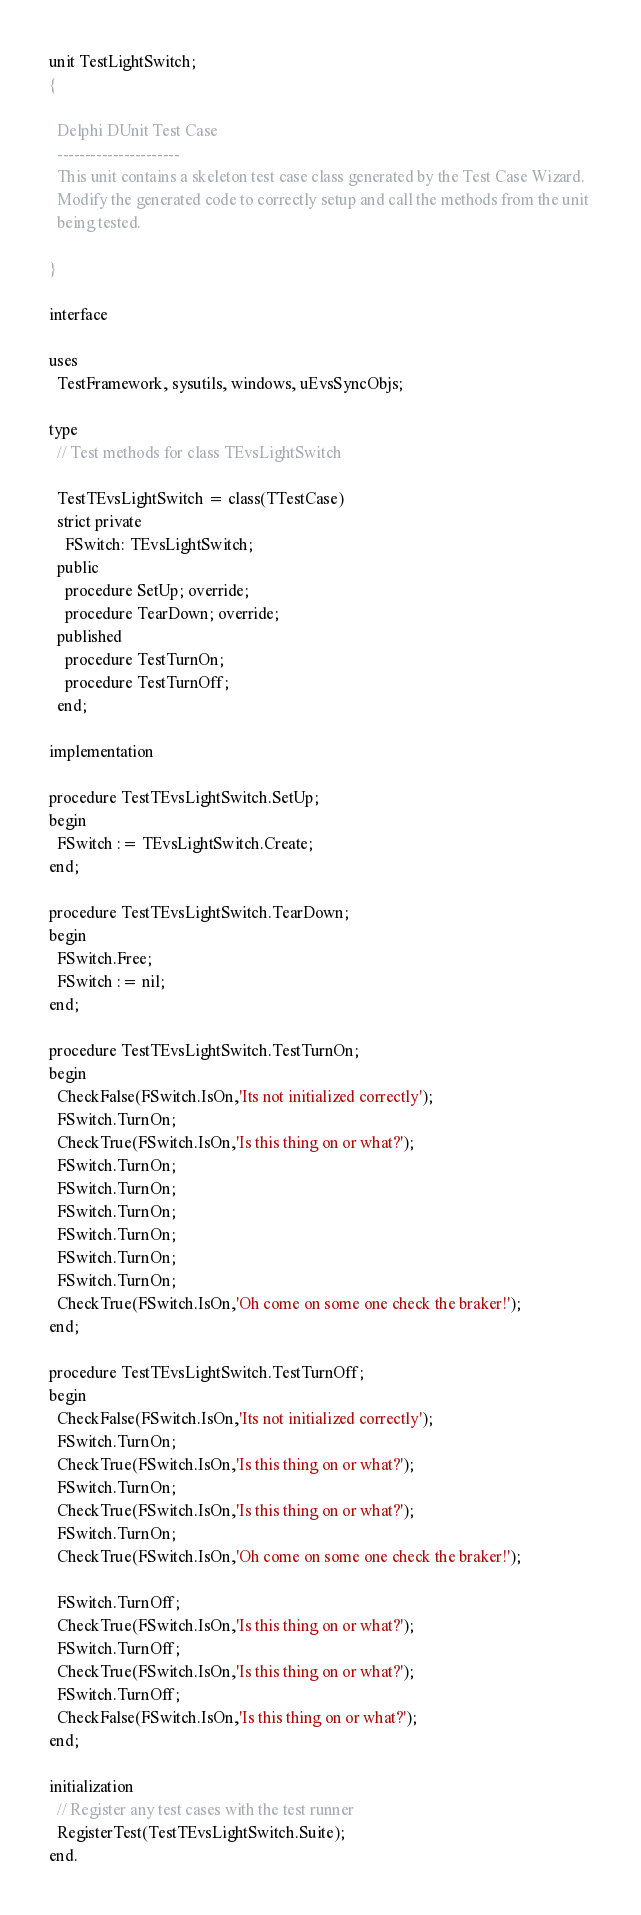Convert code to text. <code><loc_0><loc_0><loc_500><loc_500><_Pascal_>unit TestLightSwitch;
{

  Delphi DUnit Test Case
  ----------------------
  This unit contains a skeleton test case class generated by the Test Case Wizard.
  Modify the generated code to correctly setup and call the methods from the unit 
  being tested.

}

interface

uses
  TestFramework, sysutils, windows, uEvsSyncObjs;

type
  // Test methods for class TEvsLightSwitch
  
  TestTEvsLightSwitch = class(TTestCase)
  strict private
    FSwitch: TEvsLightSwitch;
  public
    procedure SetUp; override;
    procedure TearDown; override;
  published
    procedure TestTurnOn;
    procedure TestTurnOff;
  end;

implementation

procedure TestTEvsLightSwitch.SetUp;
begin
  FSwitch := TEvsLightSwitch.Create;
end;

procedure TestTEvsLightSwitch.TearDown;
begin
  FSwitch.Free;
  FSwitch := nil;
end;

procedure TestTEvsLightSwitch.TestTurnOn;
begin
  CheckFalse(FSwitch.IsOn,'Its not initialized correctly');
  FSwitch.TurnOn;
  CheckTrue(FSwitch.IsOn,'Is this thing on or what?');
  FSwitch.TurnOn;
  FSwitch.TurnOn;
  FSwitch.TurnOn;
  FSwitch.TurnOn;
  FSwitch.TurnOn;
  FSwitch.TurnOn;
  CheckTrue(FSwitch.IsOn,'Oh come on some one check the braker!');
end;

procedure TestTEvsLightSwitch.TestTurnOff;
begin
  CheckFalse(FSwitch.IsOn,'Its not initialized correctly');
  FSwitch.TurnOn;
  CheckTrue(FSwitch.IsOn,'Is this thing on or what?');
  FSwitch.TurnOn;
  CheckTrue(FSwitch.IsOn,'Is this thing on or what?');
  FSwitch.TurnOn;
  CheckTrue(FSwitch.IsOn,'Oh come on some one check the braker!');

  FSwitch.TurnOff;
  CheckTrue(FSwitch.IsOn,'Is this thing on or what?');
  FSwitch.TurnOff;
  CheckTrue(FSwitch.IsOn,'Is this thing on or what?');
  FSwitch.TurnOff;
  CheckFalse(FSwitch.IsOn,'Is this thing on or what?');
end;

initialization
  // Register any test cases with the test runner
  RegisterTest(TestTEvsLightSwitch.Suite);
end.

</code> 